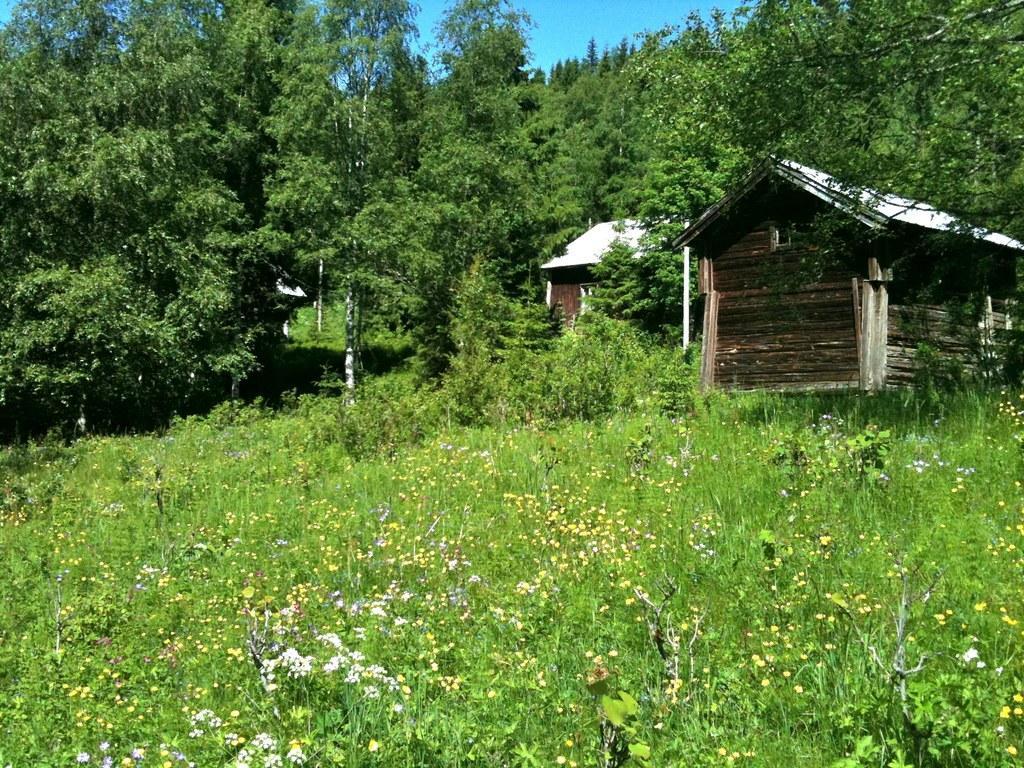Describe this image in one or two sentences. In this image we can see many plants with flowers. Also there are houses. And a house is made with wood. In the background there are trees. Also there is sky. 